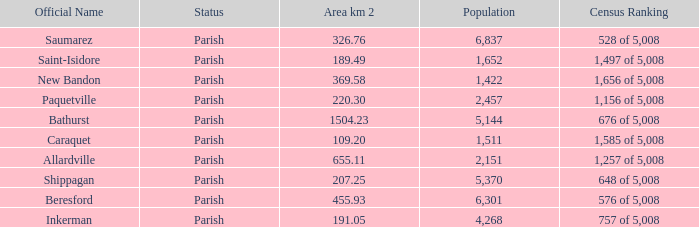What is the Area of the Allardville Parish with a Population smaller than 2,151? None. 